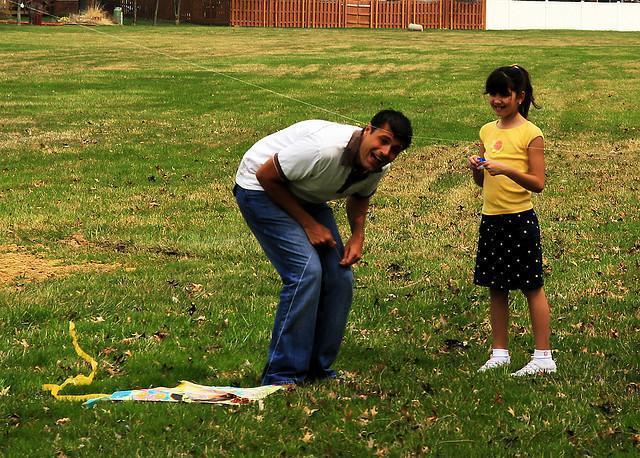How many people can be seen?
Give a very brief answer. 2. 